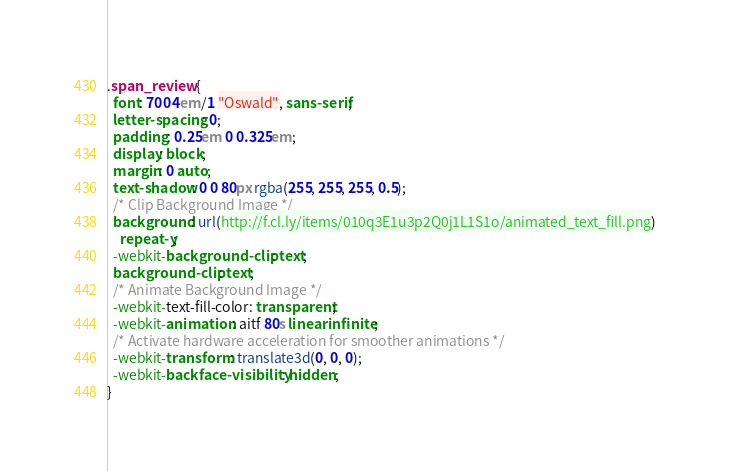<code> <loc_0><loc_0><loc_500><loc_500><_CSS_>.span_review {
  font: 700 4em/1 "Oswald", sans-serif;
  letter-spacing: 0;
  padding: 0.25em 0 0.325em;
  display: block;
  margin: 0 auto;
  text-shadow: 0 0 80px rgba(255, 255, 255, 0.5);
  /* Clip Background Image */
  background: url(http://f.cl.ly/items/010q3E1u3p2Q0j1L1S1o/animated_text_fill.png)
    repeat-y;
  -webkit-background-clip: text;
  background-clip: text;
  /* Animate Background Image */
  -webkit-text-fill-color: transparent;
  -webkit-animation: aitf 80s linear infinite;
  /* Activate hardware acceleration for smoother animations */
  -webkit-transform: translate3d(0, 0, 0);
  -webkit-backface-visibility: hidden;
}
</code> 